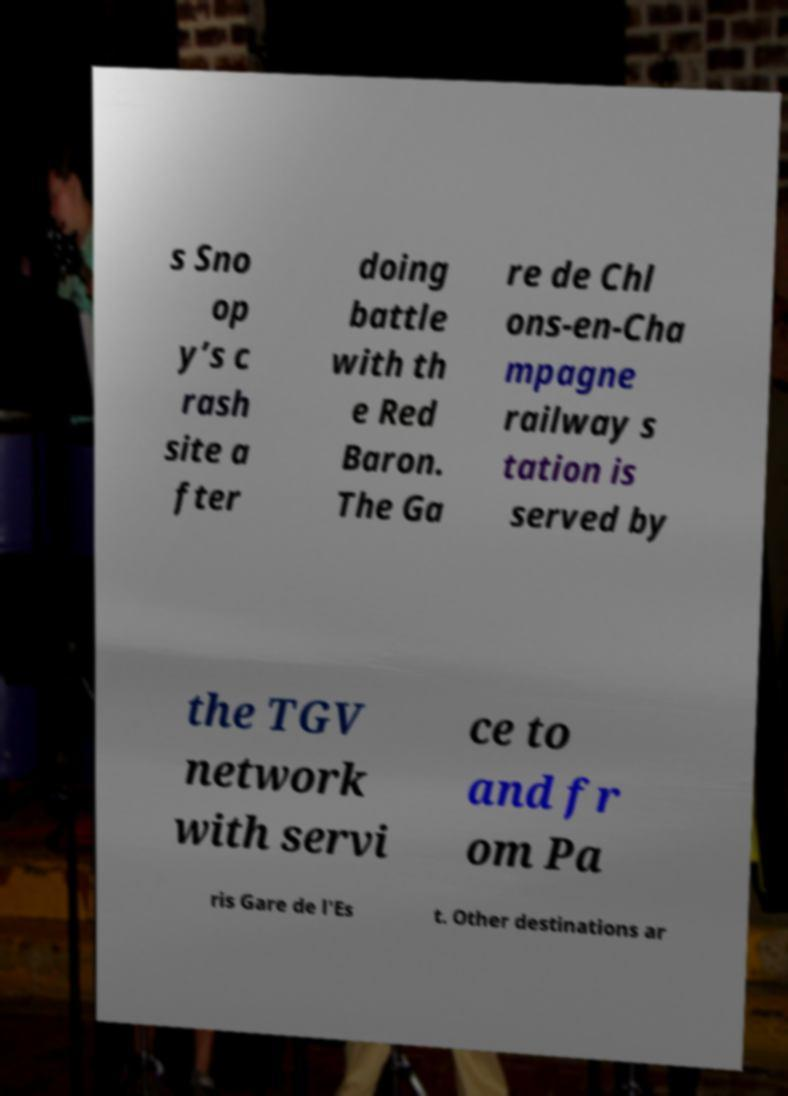What messages or text are displayed in this image? I need them in a readable, typed format. s Sno op y’s c rash site a fter doing battle with th e Red Baron. The Ga re de Chl ons-en-Cha mpagne railway s tation is served by the TGV network with servi ce to and fr om Pa ris Gare de l'Es t. Other destinations ar 